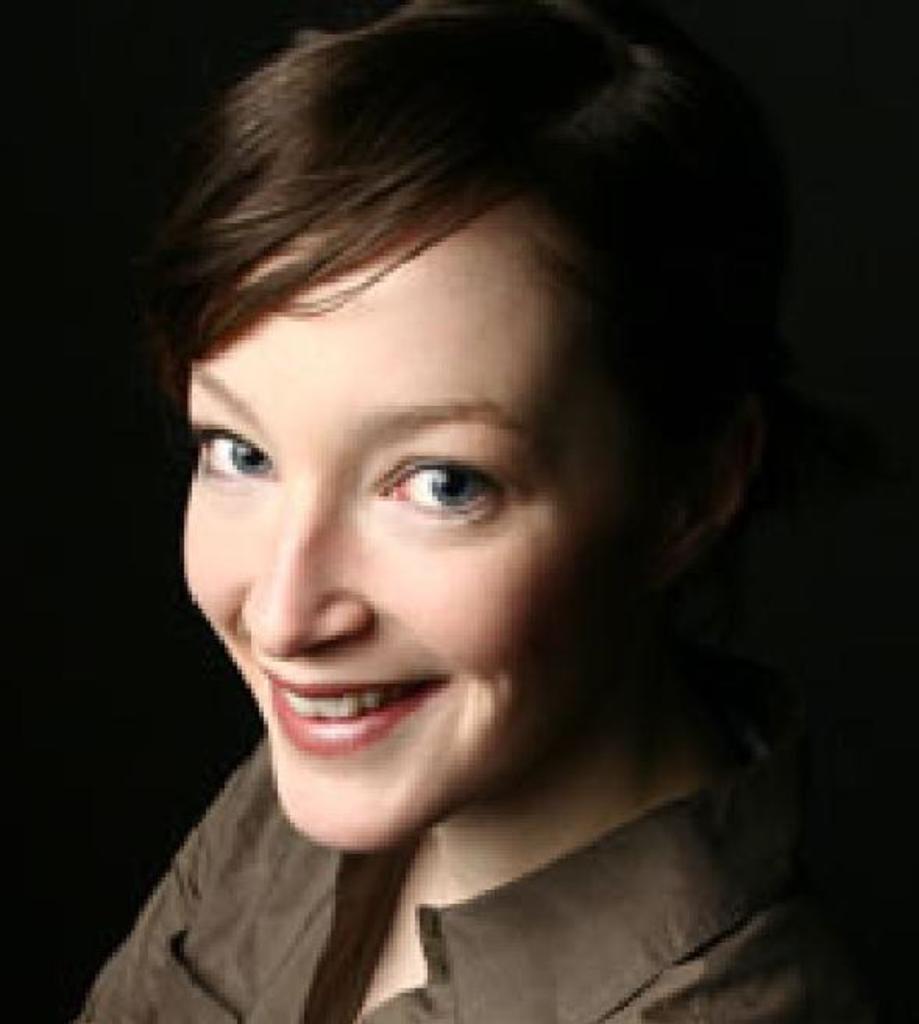Please provide a concise description of this image. There is a woman in a shirt, smiling. And the background is dark in color. 